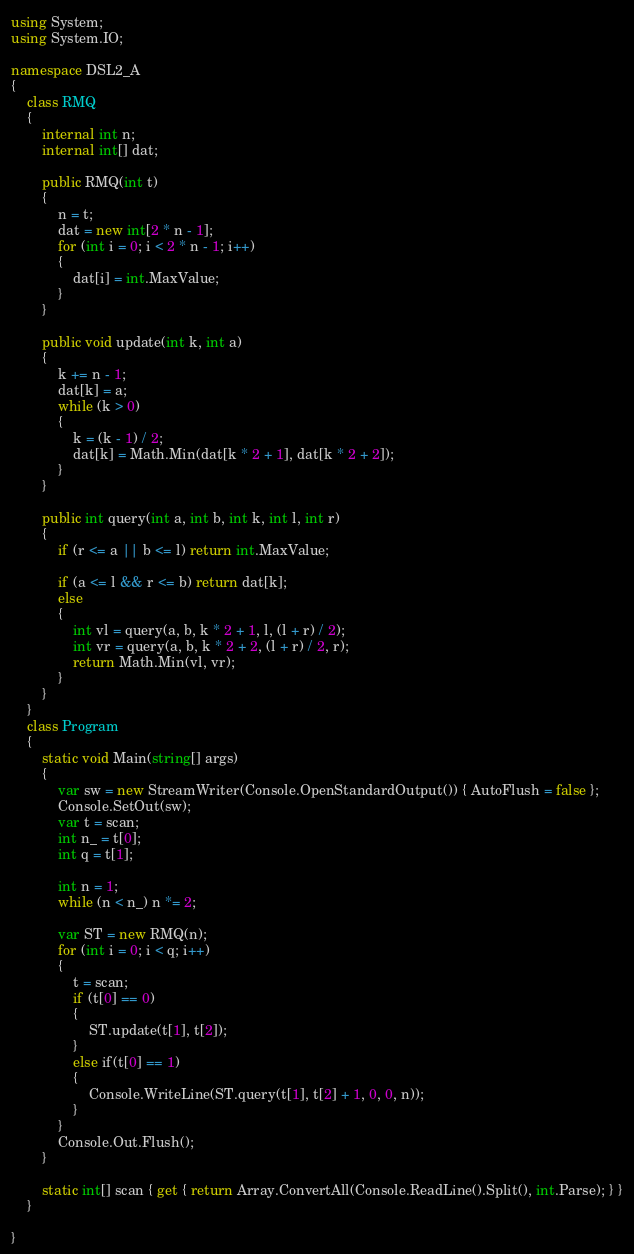Convert code to text. <code><loc_0><loc_0><loc_500><loc_500><_C#_>using System;
using System.IO;

namespace DSL2_A
{
    class RMQ
    {
        internal int n;
        internal int[] dat;

        public RMQ(int t)
        {
            n = t;
            dat = new int[2 * n - 1];
            for (int i = 0; i < 2 * n - 1; i++)
            {
                dat[i] = int.MaxValue;
            }
        }

        public void update(int k, int a)
        {
            k += n - 1;
            dat[k] = a;
            while (k > 0)
            {
                k = (k - 1) / 2;
                dat[k] = Math.Min(dat[k * 2 + 1], dat[k * 2 + 2]);
            }  
        }

        public int query(int a, int b, int k, int l, int r)
        {
            if (r <= a || b <= l) return int.MaxValue;

            if (a <= l && r <= b) return dat[k];
            else
            {
                int vl = query(a, b, k * 2 + 1, l, (l + r) / 2);
                int vr = query(a, b, k * 2 + 2, (l + r) / 2, r);
                return Math.Min(vl, vr);
            }
        }
    }
    class Program
    {
        static void Main(string[] args)
        {
            var sw = new StreamWriter(Console.OpenStandardOutput()) { AutoFlush = false };
            Console.SetOut(sw);
            var t = scan;
            int n_ = t[0];
            int q = t[1];

            int n = 1;
            while (n < n_) n *= 2;

            var ST = new RMQ(n);
            for (int i = 0; i < q; i++)
            {
                t = scan;
                if (t[0] == 0)
                {
                    ST.update(t[1], t[2]);
                }
                else if(t[0] == 1)
                {
                    Console.WriteLine(ST.query(t[1], t[2] + 1, 0, 0, n));
                }
            }
            Console.Out.Flush();
        }

        static int[] scan { get { return Array.ConvertAll(Console.ReadLine().Split(), int.Parse); } }
    }

}</code> 